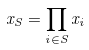Convert formula to latex. <formula><loc_0><loc_0><loc_500><loc_500>x _ { S } = \prod _ { i \in S } x _ { i }</formula> 